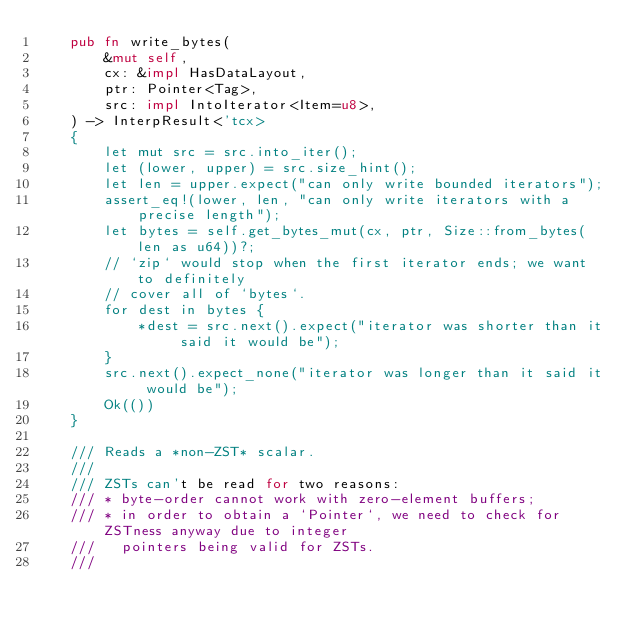Convert code to text. <code><loc_0><loc_0><loc_500><loc_500><_Rust_>    pub fn write_bytes(
        &mut self,
        cx: &impl HasDataLayout,
        ptr: Pointer<Tag>,
        src: impl IntoIterator<Item=u8>,
    ) -> InterpResult<'tcx>
    {
        let mut src = src.into_iter();
        let (lower, upper) = src.size_hint();
        let len = upper.expect("can only write bounded iterators");
        assert_eq!(lower, len, "can only write iterators with a precise length");
        let bytes = self.get_bytes_mut(cx, ptr, Size::from_bytes(len as u64))?;
        // `zip` would stop when the first iterator ends; we want to definitely
        // cover all of `bytes`.
        for dest in bytes {
            *dest = src.next().expect("iterator was shorter than it said it would be");
        }
        src.next().expect_none("iterator was longer than it said it would be");
        Ok(())
    }

    /// Reads a *non-ZST* scalar.
    ///
    /// ZSTs can't be read for two reasons:
    /// * byte-order cannot work with zero-element buffers;
    /// * in order to obtain a `Pointer`, we need to check for ZSTness anyway due to integer
    ///   pointers being valid for ZSTs.
    ///</code> 